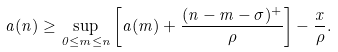Convert formula to latex. <formula><loc_0><loc_0><loc_500><loc_500>a ( n ) \geq \sup _ { 0 \leq m \leq n } \left [ a ( m ) + \frac { ( n - m - \sigma ) ^ { + } } { \rho } \right ] - \frac { x } { \rho } .</formula> 